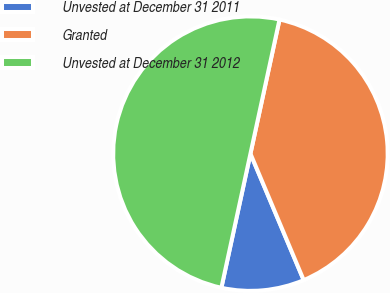Convert chart. <chart><loc_0><loc_0><loc_500><loc_500><pie_chart><fcel>Unvested at December 31 2011<fcel>Granted<fcel>Unvested at December 31 2012<nl><fcel>9.74%<fcel>40.26%<fcel>50.0%<nl></chart> 